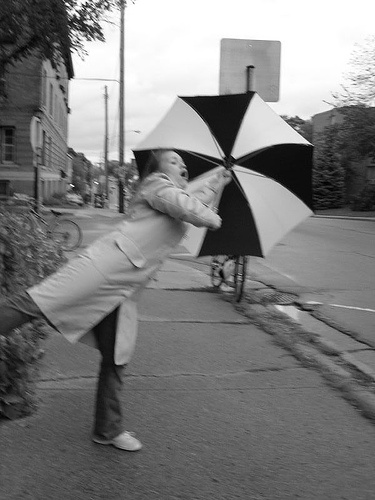Describe the objects in this image and their specific colors. I can see people in black, darkgray, gray, and lightgray tones, umbrella in black, lightgray, darkgray, and gray tones, bicycle in gray and black tones, bicycle in gray and black tones, and stop sign in dimgray, darkgray, black, and gray tones in this image. 